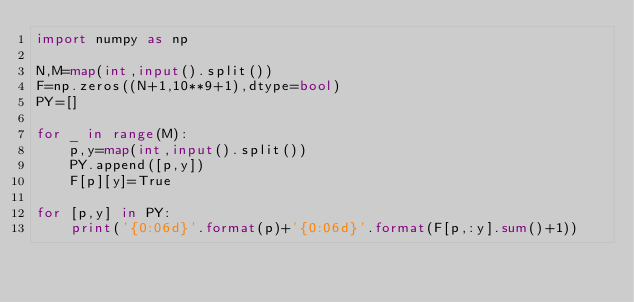<code> <loc_0><loc_0><loc_500><loc_500><_Python_>import numpy as np

N,M=map(int,input().split())
F=np.zeros((N+1,10**9+1),dtype=bool)
PY=[]
 
for _ in range(M):
    p,y=map(int,input().split())
    PY.append([p,y])
    F[p][y]=True

for [p,y] in PY:
    print('{0:06d}'.format(p)+'{0:06d}'.format(F[p,:y].sum()+1))
</code> 